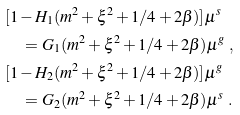<formula> <loc_0><loc_0><loc_500><loc_500>& [ 1 - H _ { 1 } ( m ^ { 2 } + \xi ^ { 2 } + 1 / 4 + 2 \beta ) ] \mu ^ { s } \\ & \quad = G _ { 1 } ( m ^ { 2 } + \xi ^ { 2 } + 1 / 4 + 2 \beta ) \mu ^ { g } \ , \\ & [ 1 - H _ { 2 } ( m ^ { 2 } + \xi ^ { 2 } + 1 / 4 + 2 \beta ) ] \mu ^ { g } \\ & \quad = G _ { 2 } ( m ^ { 2 } + \xi ^ { 2 } + 1 / 4 + 2 \beta ) \mu ^ { s } \ .</formula> 